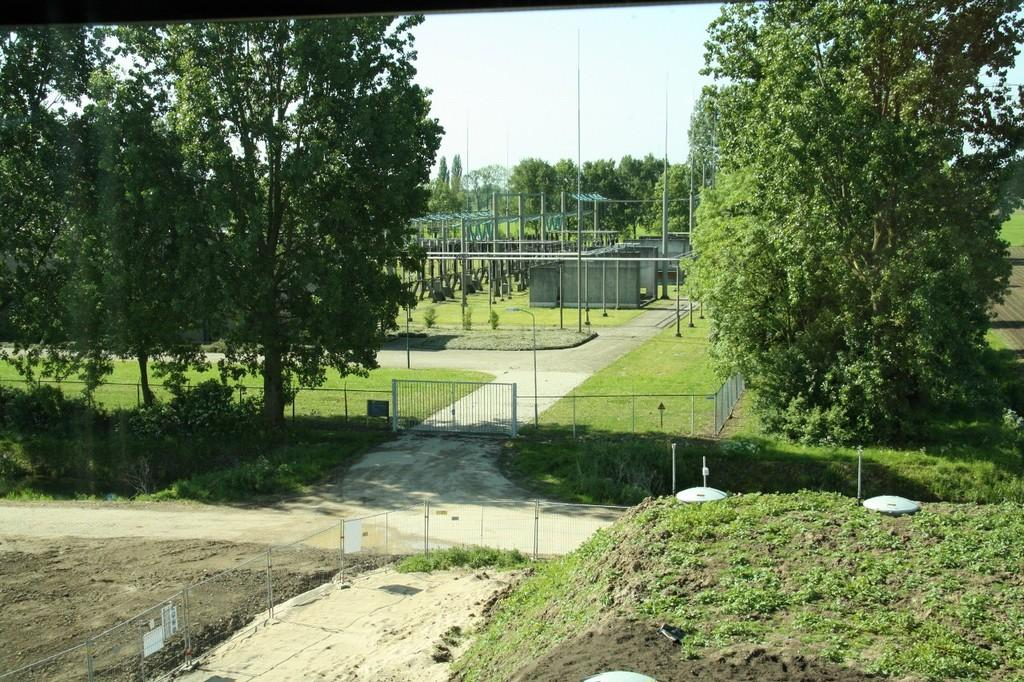What is located in the center of the image? There are trees, a mesh, a gate, poles, and machines in the center of the image. What type of vegetation can be seen in the image? There are trees and grass visible in the image. What is present at the bottom of the image? There is ground, grass, and boards visible at the bottom of the image. What is visible at the top of the image? The sky is visible at the top of the image. Can you see any coal or smoke coming from the machines in the image? There is no mention of coal or smoke in the image, and therefore we cannot determine if they are present. Is there a rifle visible in the image? There is no rifle present in the image. 